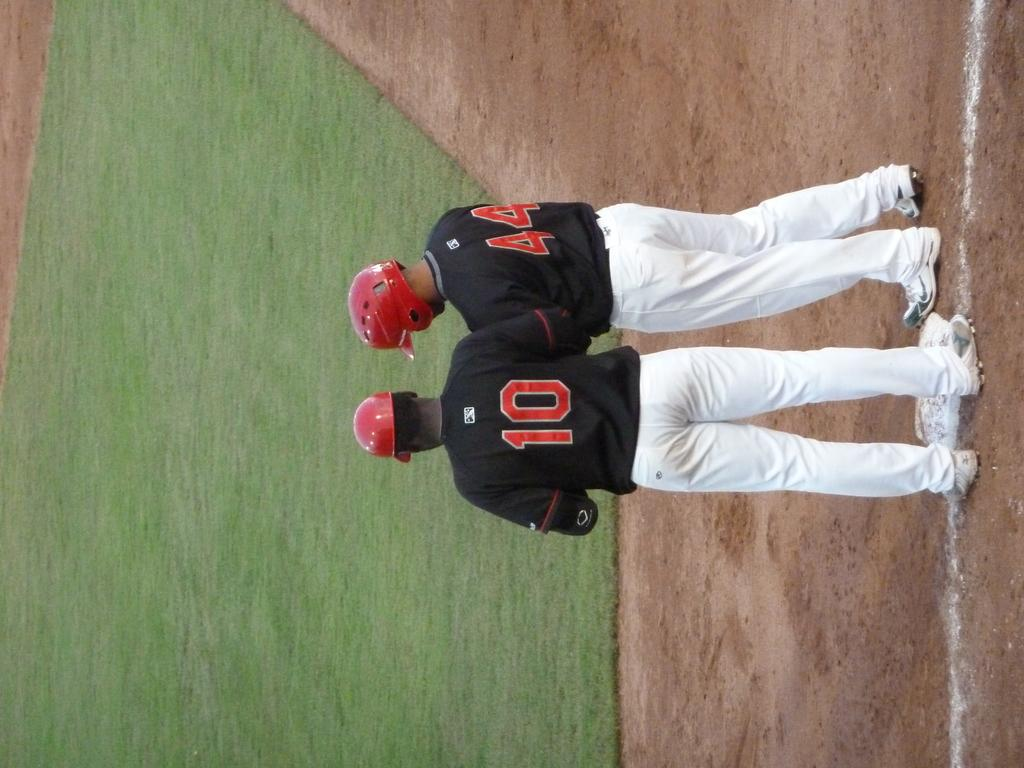<image>
Create a compact narrative representing the image presented. Two baseball players on the field, their numbers are 10 and 44. 